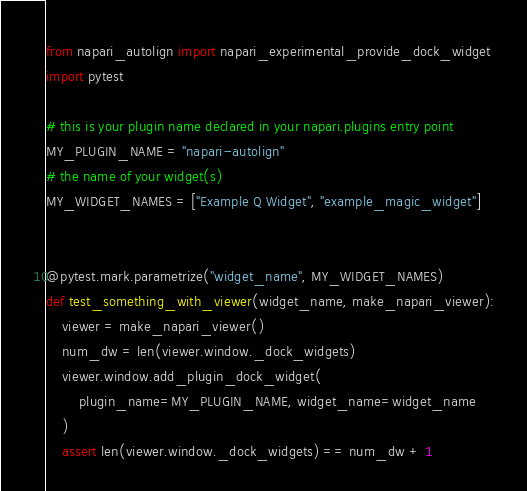<code> <loc_0><loc_0><loc_500><loc_500><_Python_>from napari_autolign import napari_experimental_provide_dock_widget
import pytest

# this is your plugin name declared in your napari.plugins entry point
MY_PLUGIN_NAME = "napari-autolign"
# the name of your widget(s)
MY_WIDGET_NAMES = ["Example Q Widget", "example_magic_widget"]


@pytest.mark.parametrize("widget_name", MY_WIDGET_NAMES)
def test_something_with_viewer(widget_name, make_napari_viewer):
    viewer = make_napari_viewer()
    num_dw = len(viewer.window._dock_widgets)
    viewer.window.add_plugin_dock_widget(
        plugin_name=MY_PLUGIN_NAME, widget_name=widget_name
    )
    assert len(viewer.window._dock_widgets) == num_dw + 1
</code> 